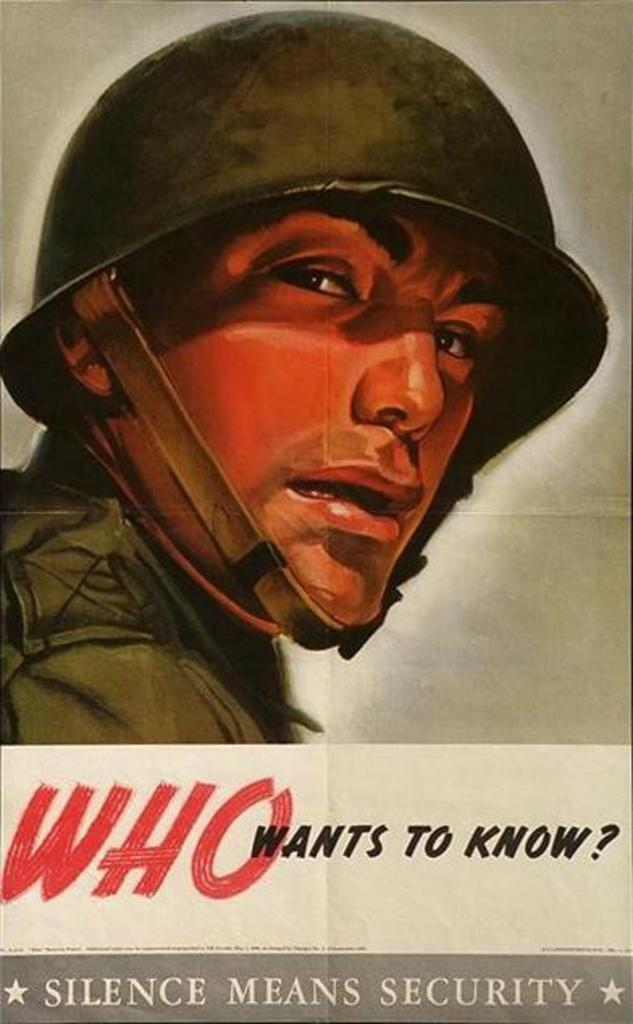<image>
Render a clear and concise summary of the photo. A picture of a man in an army uniform includes the phrase who wants to know below it. 